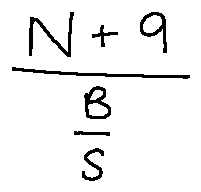<formula> <loc_0><loc_0><loc_500><loc_500>\frac { N + 9 } { \frac { B } { S } }</formula> 